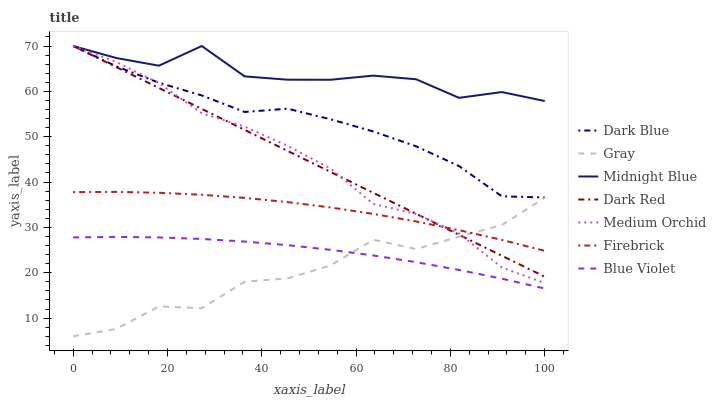Does Gray have the minimum area under the curve?
Answer yes or no. Yes. Does Midnight Blue have the maximum area under the curve?
Answer yes or no. Yes. Does Dark Red have the minimum area under the curve?
Answer yes or no. No. Does Dark Red have the maximum area under the curve?
Answer yes or no. No. Is Dark Red the smoothest?
Answer yes or no. Yes. Is Gray the roughest?
Answer yes or no. Yes. Is Midnight Blue the smoothest?
Answer yes or no. No. Is Midnight Blue the roughest?
Answer yes or no. No. Does Gray have the lowest value?
Answer yes or no. Yes. Does Dark Red have the lowest value?
Answer yes or no. No. Does Dark Blue have the highest value?
Answer yes or no. Yes. Does Firebrick have the highest value?
Answer yes or no. No. Is Gray less than Dark Blue?
Answer yes or no. Yes. Is Firebrick greater than Blue Violet?
Answer yes or no. Yes. Does Dark Red intersect Gray?
Answer yes or no. Yes. Is Dark Red less than Gray?
Answer yes or no. No. Is Dark Red greater than Gray?
Answer yes or no. No. Does Gray intersect Dark Blue?
Answer yes or no. No. 